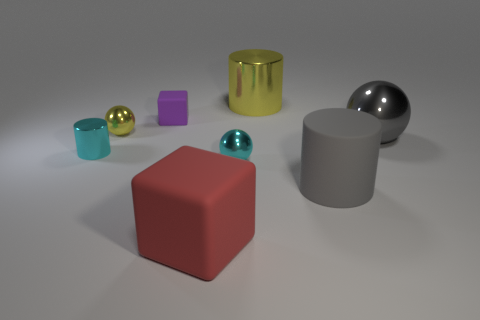There is a big cylinder that is in front of the block that is behind the large gray thing that is behind the small cyan metallic cylinder; what is its material?
Offer a very short reply. Rubber. There is a metal cylinder that is on the left side of the purple rubber block; is its size the same as the red thing?
Provide a short and direct response. No. What material is the big red cube in front of the small cyan metal ball?
Provide a short and direct response. Rubber. Is the number of large gray rubber objects greater than the number of cylinders?
Make the answer very short. No. How many objects are big cylinders behind the tiny cube or large yellow objects?
Make the answer very short. 1. There is a big thing that is left of the yellow cylinder; how many large matte objects are to the right of it?
Provide a short and direct response. 1. There is a cube behind the metal cylinder to the left of the small metallic ball that is behind the gray metallic object; what is its size?
Provide a succinct answer. Small. There is a tiny metallic thing behind the gray shiny ball; does it have the same color as the big rubber cylinder?
Ensure brevity in your answer.  No. There is a yellow thing that is the same shape as the large gray matte thing; what is its size?
Ensure brevity in your answer.  Large. How many objects are either small cyan cylinders to the left of the big cube or objects that are to the left of the large gray metal ball?
Provide a succinct answer. 7. 